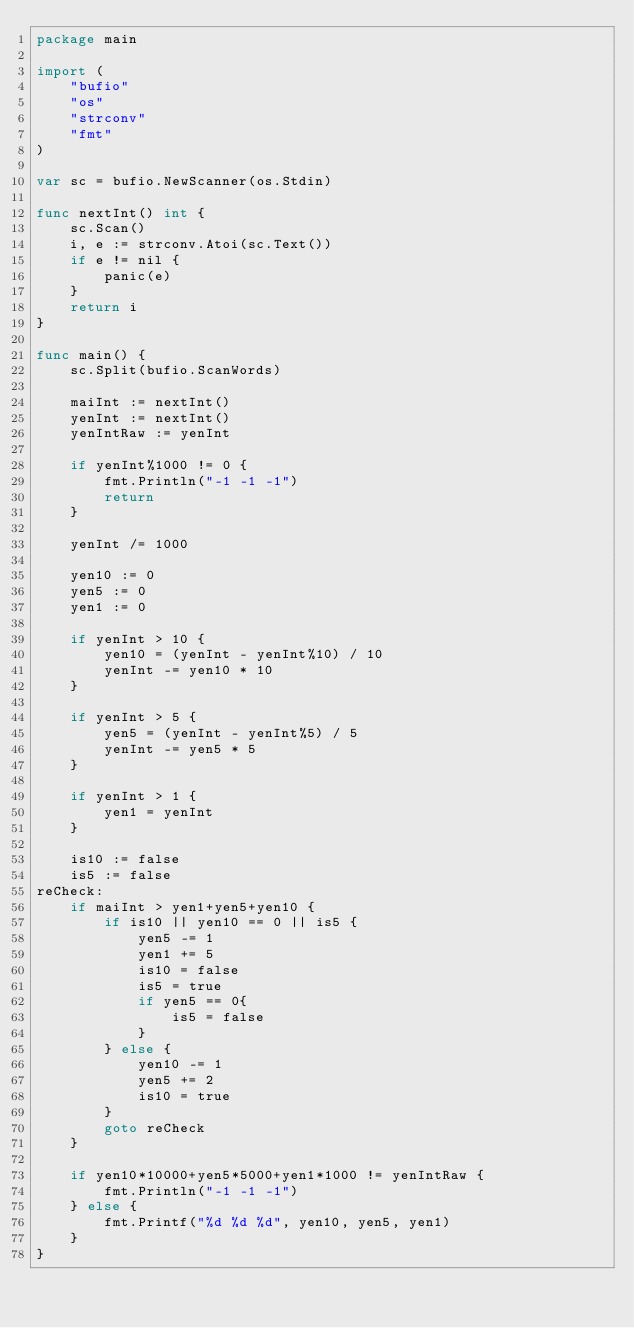Convert code to text. <code><loc_0><loc_0><loc_500><loc_500><_Go_>package main

import (
	"bufio"
	"os"
	"strconv"
	"fmt"
)

var sc = bufio.NewScanner(os.Stdin)

func nextInt() int {
	sc.Scan()
	i, e := strconv.Atoi(sc.Text())
	if e != nil {
		panic(e)
	}
	return i
}

func main() {
	sc.Split(bufio.ScanWords)

	maiInt := nextInt()
	yenInt := nextInt()
	yenIntRaw := yenInt

	if yenInt%1000 != 0 {
		fmt.Println("-1 -1 -1")
		return
	}

	yenInt /= 1000

	yen10 := 0
	yen5 := 0
	yen1 := 0

	if yenInt > 10 {
		yen10 = (yenInt - yenInt%10) / 10
		yenInt -= yen10 * 10
	}

	if yenInt > 5 {
		yen5 = (yenInt - yenInt%5) / 5
		yenInt -= yen5 * 5
	}

	if yenInt > 1 {
		yen1 = yenInt
	}

	is10 := false
	is5 := false
reCheck:
	if maiInt > yen1+yen5+yen10 {
		if is10 || yen10 == 0 || is5 {
			yen5 -= 1
			yen1 += 5
			is10 = false
			is5 = true
			if yen5 == 0{
				is5 = false
			}
		} else {
			yen10 -= 1
			yen5 += 2
			is10 = true
		}
		goto reCheck
	}

	if yen10*10000+yen5*5000+yen1*1000 != yenIntRaw {
		fmt.Println("-1 -1 -1")
	} else {
		fmt.Printf("%d %d %d", yen10, yen5, yen1)
	}
}
</code> 